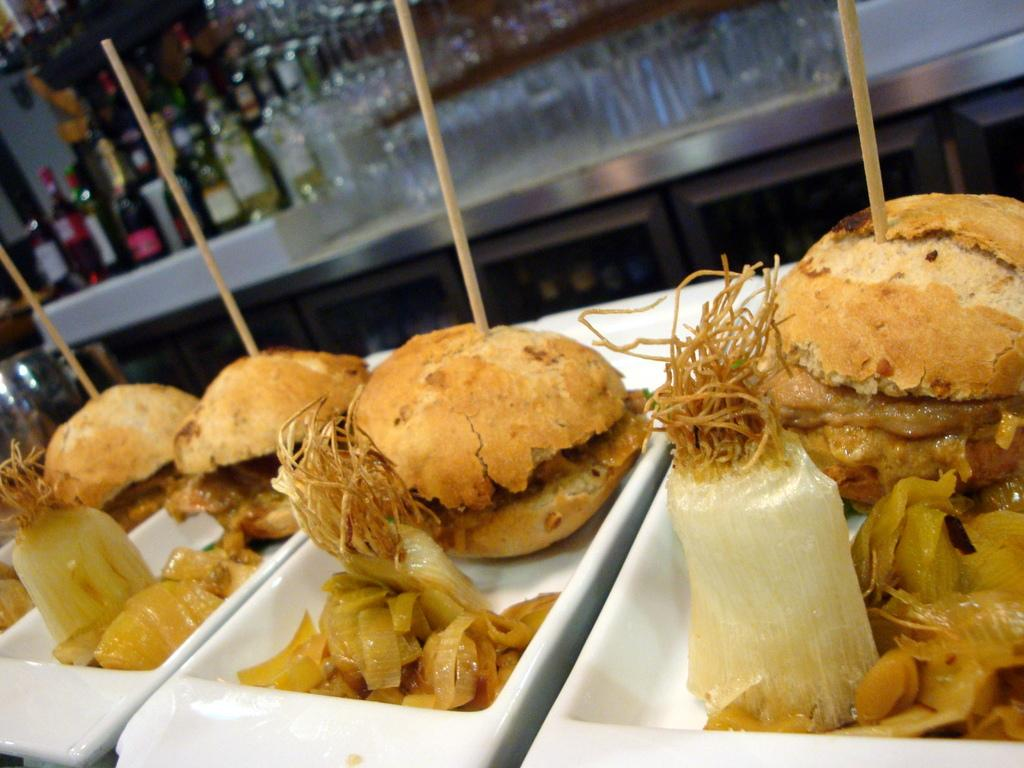What type of plates are visible in the image? There are white plates in the image. What is on the plates? There are burgers on the plates. What else can be seen on the plates besides the burgers? There is food on the plates. Can you describe the background of the image? The background of the image is blurred. What other items are on the table besides the plates? There are bottles and glasses on the table. What is unique about the burgers in the image? The burgers have sticks in them. How does the sponge contribute to the taste of the burgers in the image? There is no sponge present in the image, so it cannot contribute to the taste of the burgers. 